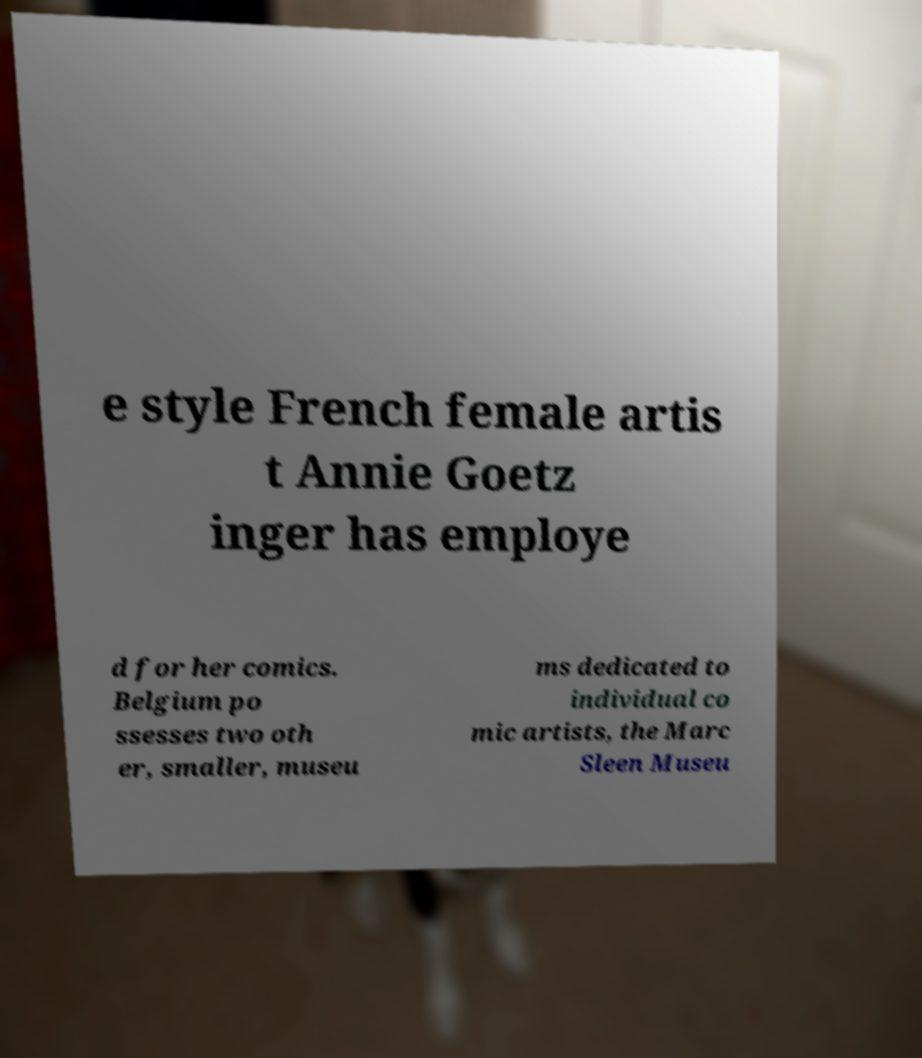Can you accurately transcribe the text from the provided image for me? e style French female artis t Annie Goetz inger has employe d for her comics. Belgium po ssesses two oth er, smaller, museu ms dedicated to individual co mic artists, the Marc Sleen Museu 